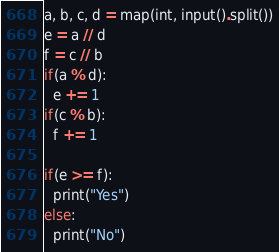Convert code to text. <code><loc_0><loc_0><loc_500><loc_500><_Python_>a, b, c, d = map(int, input().split())
e = a // d 
f = c // b
if(a % d):
  e += 1
if(c % b):
  f += 1

if(e >= f):
  print("Yes")
else:
  print("No")</code> 